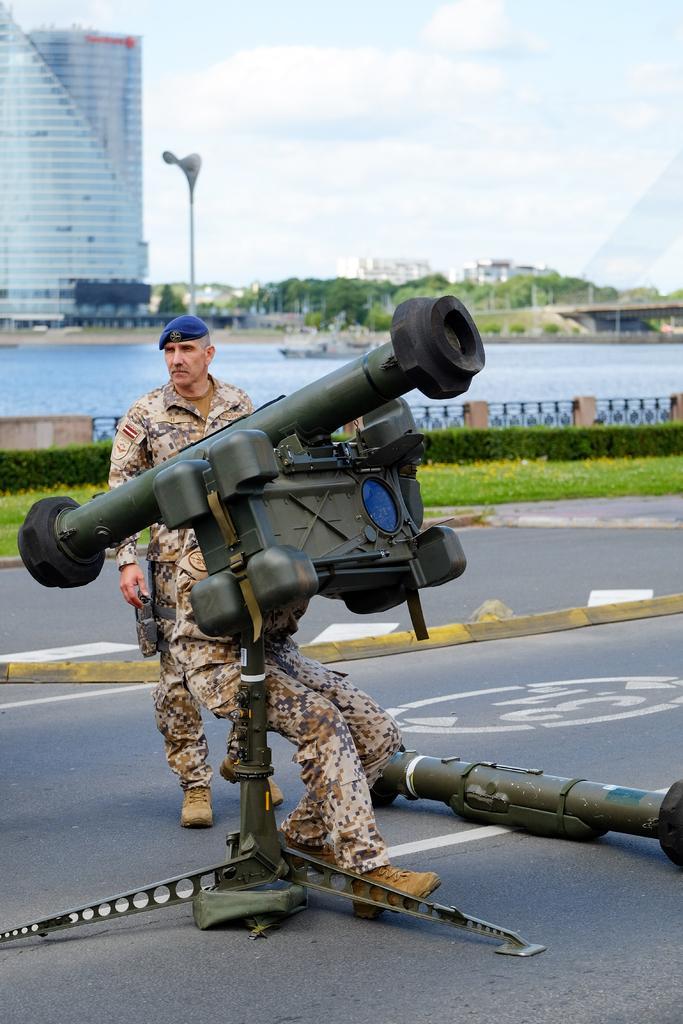Describe this image in one or two sentences. In the center of the image we can see person standing with weapon on the road. In the background we can see water, ship, buildings, trees, bridge, sky and clouds. 